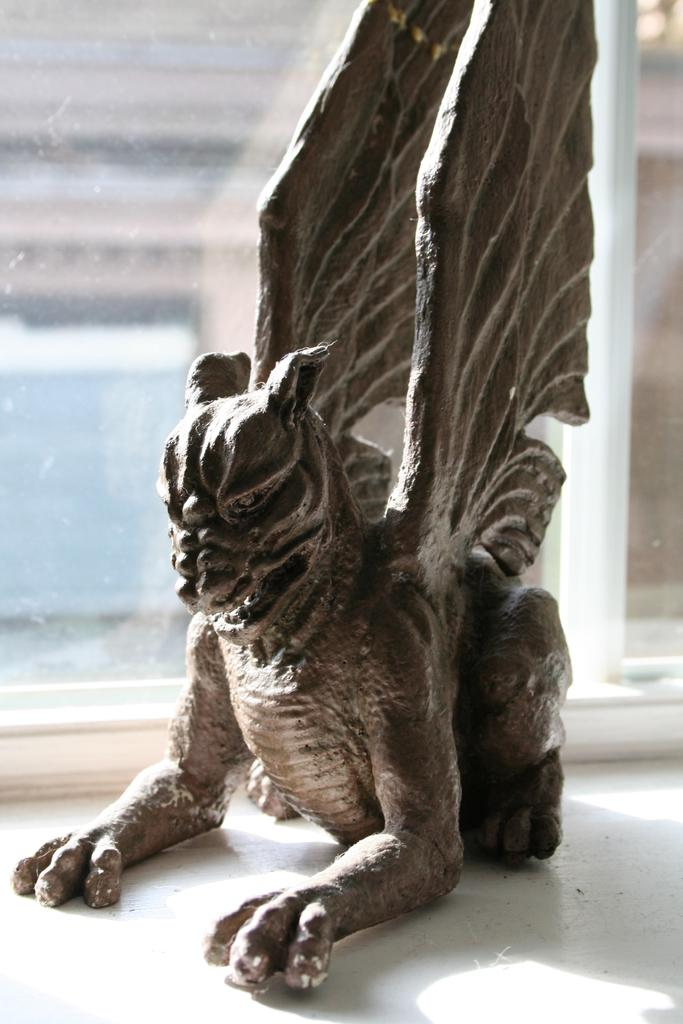What type of statue is depicted in the image? There is a statue of an animal with wings in the image. Can you describe the background of the image? There is a window visible in the background of the image. What type of rifle is being used to paint the books in the image? There are no rifles or books present in the image; it only features a statue of an animal with wings and a window in the background. 